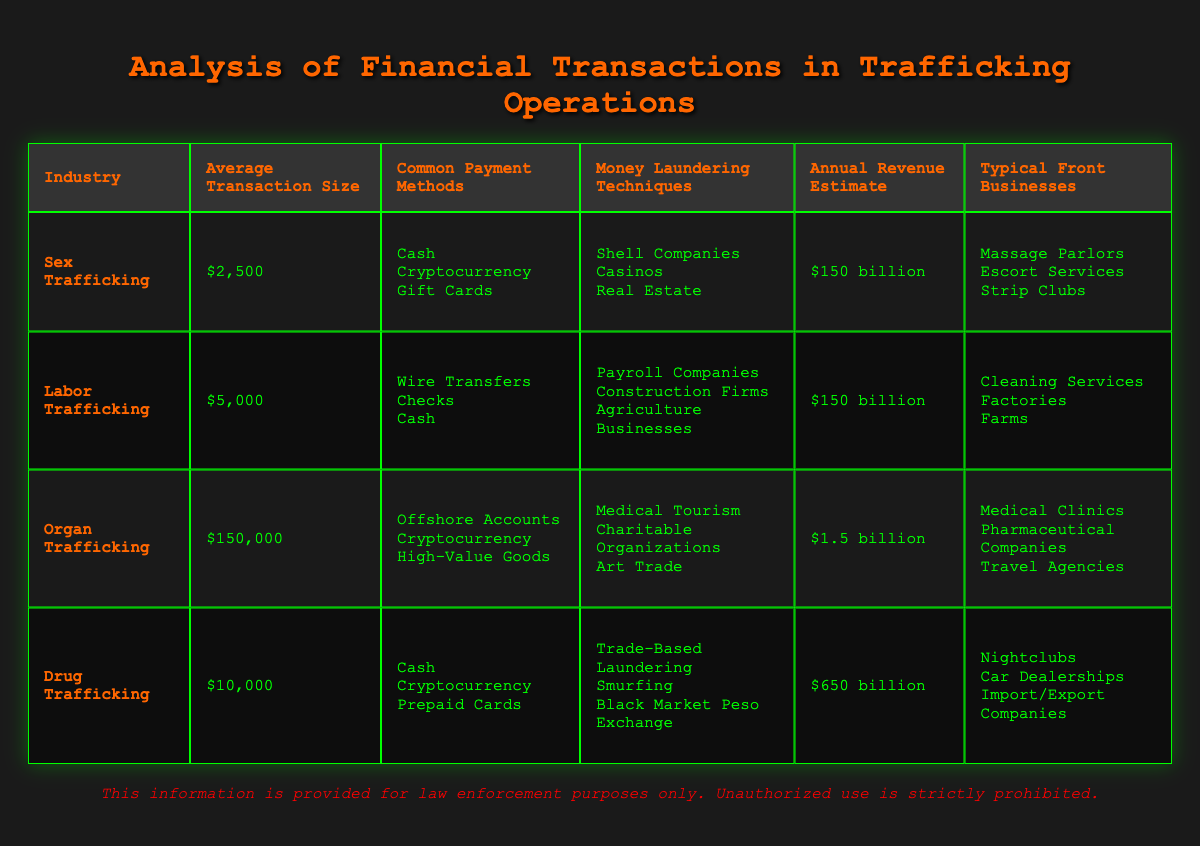What is the average transaction size in the Drug Trafficking industry? The table states that the average transaction size for Drug Trafficking is listed as $10,000.
Answer: $10,000 Which industry has the highest annual revenue estimate? According to the table, Drug Trafficking has the highest annual revenue estimate at $650 billion, compared to $150 billion for both Sex and Labor Trafficking and $1.5 billion for Organ Trafficking.
Answer: Drug Trafficking How many common payment methods are listed for Organ Trafficking? The table contains three common payment methods for Organ Trafficking: Offshore Accounts, Cryptocurrency, and High-Value Goods. Therefore, there are 3 common payment methods in total.
Answer: 3 Is it true that Labor Trafficking uses Shell Companies as a money laundering technique? The data shows that Labor Trafficking employs payroll companies, construction firms, and agriculture businesses for money laundering, which does not include Shell Companies. Therefore, the statement is false.
Answer: No What is the difference in average transaction size between Organ Trafficking and Sex Trafficking? The average transaction size for Organ Trafficking is $150,000, while for Sex Trafficking it is $2,500. To find the difference, we subtract: $150,000 - $2,500 = $147,500.
Answer: $147,500 In which industry does Cryptocurrency appear as a common payment method? The table lists Cryptocurrency as a common payment method in the following industries: Sex Trafficking, Organ Trafficking, and Drug Trafficking. Therefore, Cryptocurrency appears in 3 industries.
Answer: 3 industries Which industry has the lowest annual revenue estimate? When comparing annual revenue estimates, Organ Trafficking has the lowest estimate at $1.5 billion, which is significantly lower than the $150 billion for Sex and Labor Trafficking and the $650 billion for Drug Trafficking.
Answer: Organ Trafficking List the money laundering techniques used in the Drug Trafficking industry. The table specifies the money laundering techniques for Drug Trafficking as Trade-Based Laundering, Smurfing, and Black Market Peso Exchange. This provides a complete list of the techniques used in this industry.
Answer: Trade-Based Laundering, Smurfing, Black Market Peso Exchange 